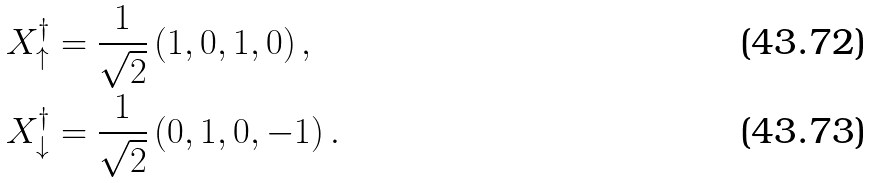Convert formula to latex. <formula><loc_0><loc_0><loc_500><loc_500>X _ { \uparrow } ^ { \dagger } & = \frac { 1 } { \sqrt { 2 } } \left ( 1 , 0 , 1 , 0 \right ) , \\ X _ { \downarrow } ^ { \dagger } & = \frac { 1 } { \sqrt { 2 } } \left ( 0 , 1 , 0 , - 1 \right ) .</formula> 